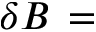Convert formula to latex. <formula><loc_0><loc_0><loc_500><loc_500>\delta B \, =</formula> 